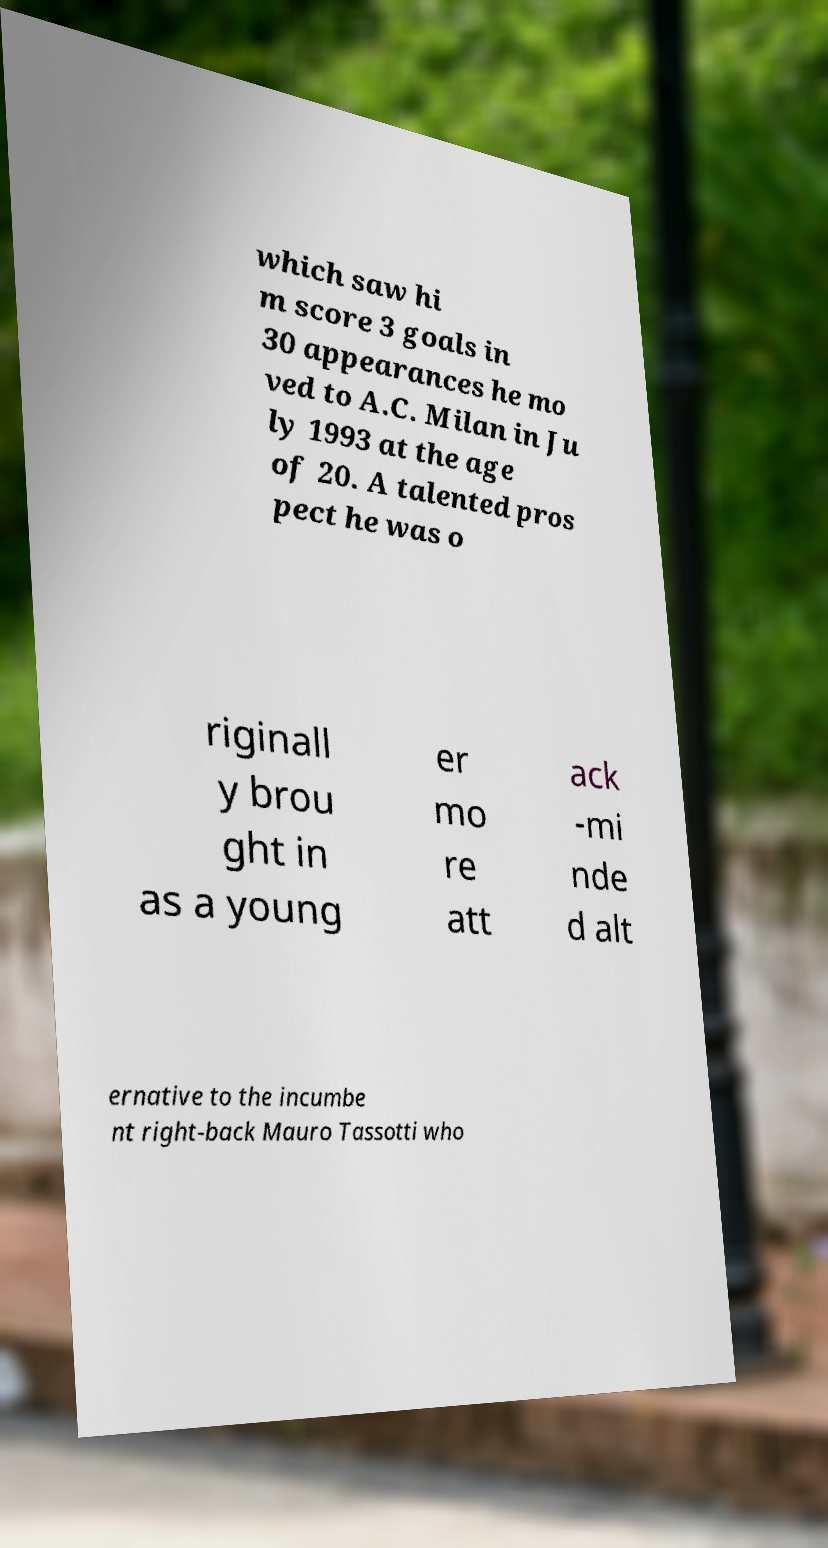Please read and relay the text visible in this image. What does it say? which saw hi m score 3 goals in 30 appearances he mo ved to A.C. Milan in Ju ly 1993 at the age of 20. A talented pros pect he was o riginall y brou ght in as a young er mo re att ack -mi nde d alt ernative to the incumbe nt right-back Mauro Tassotti who 